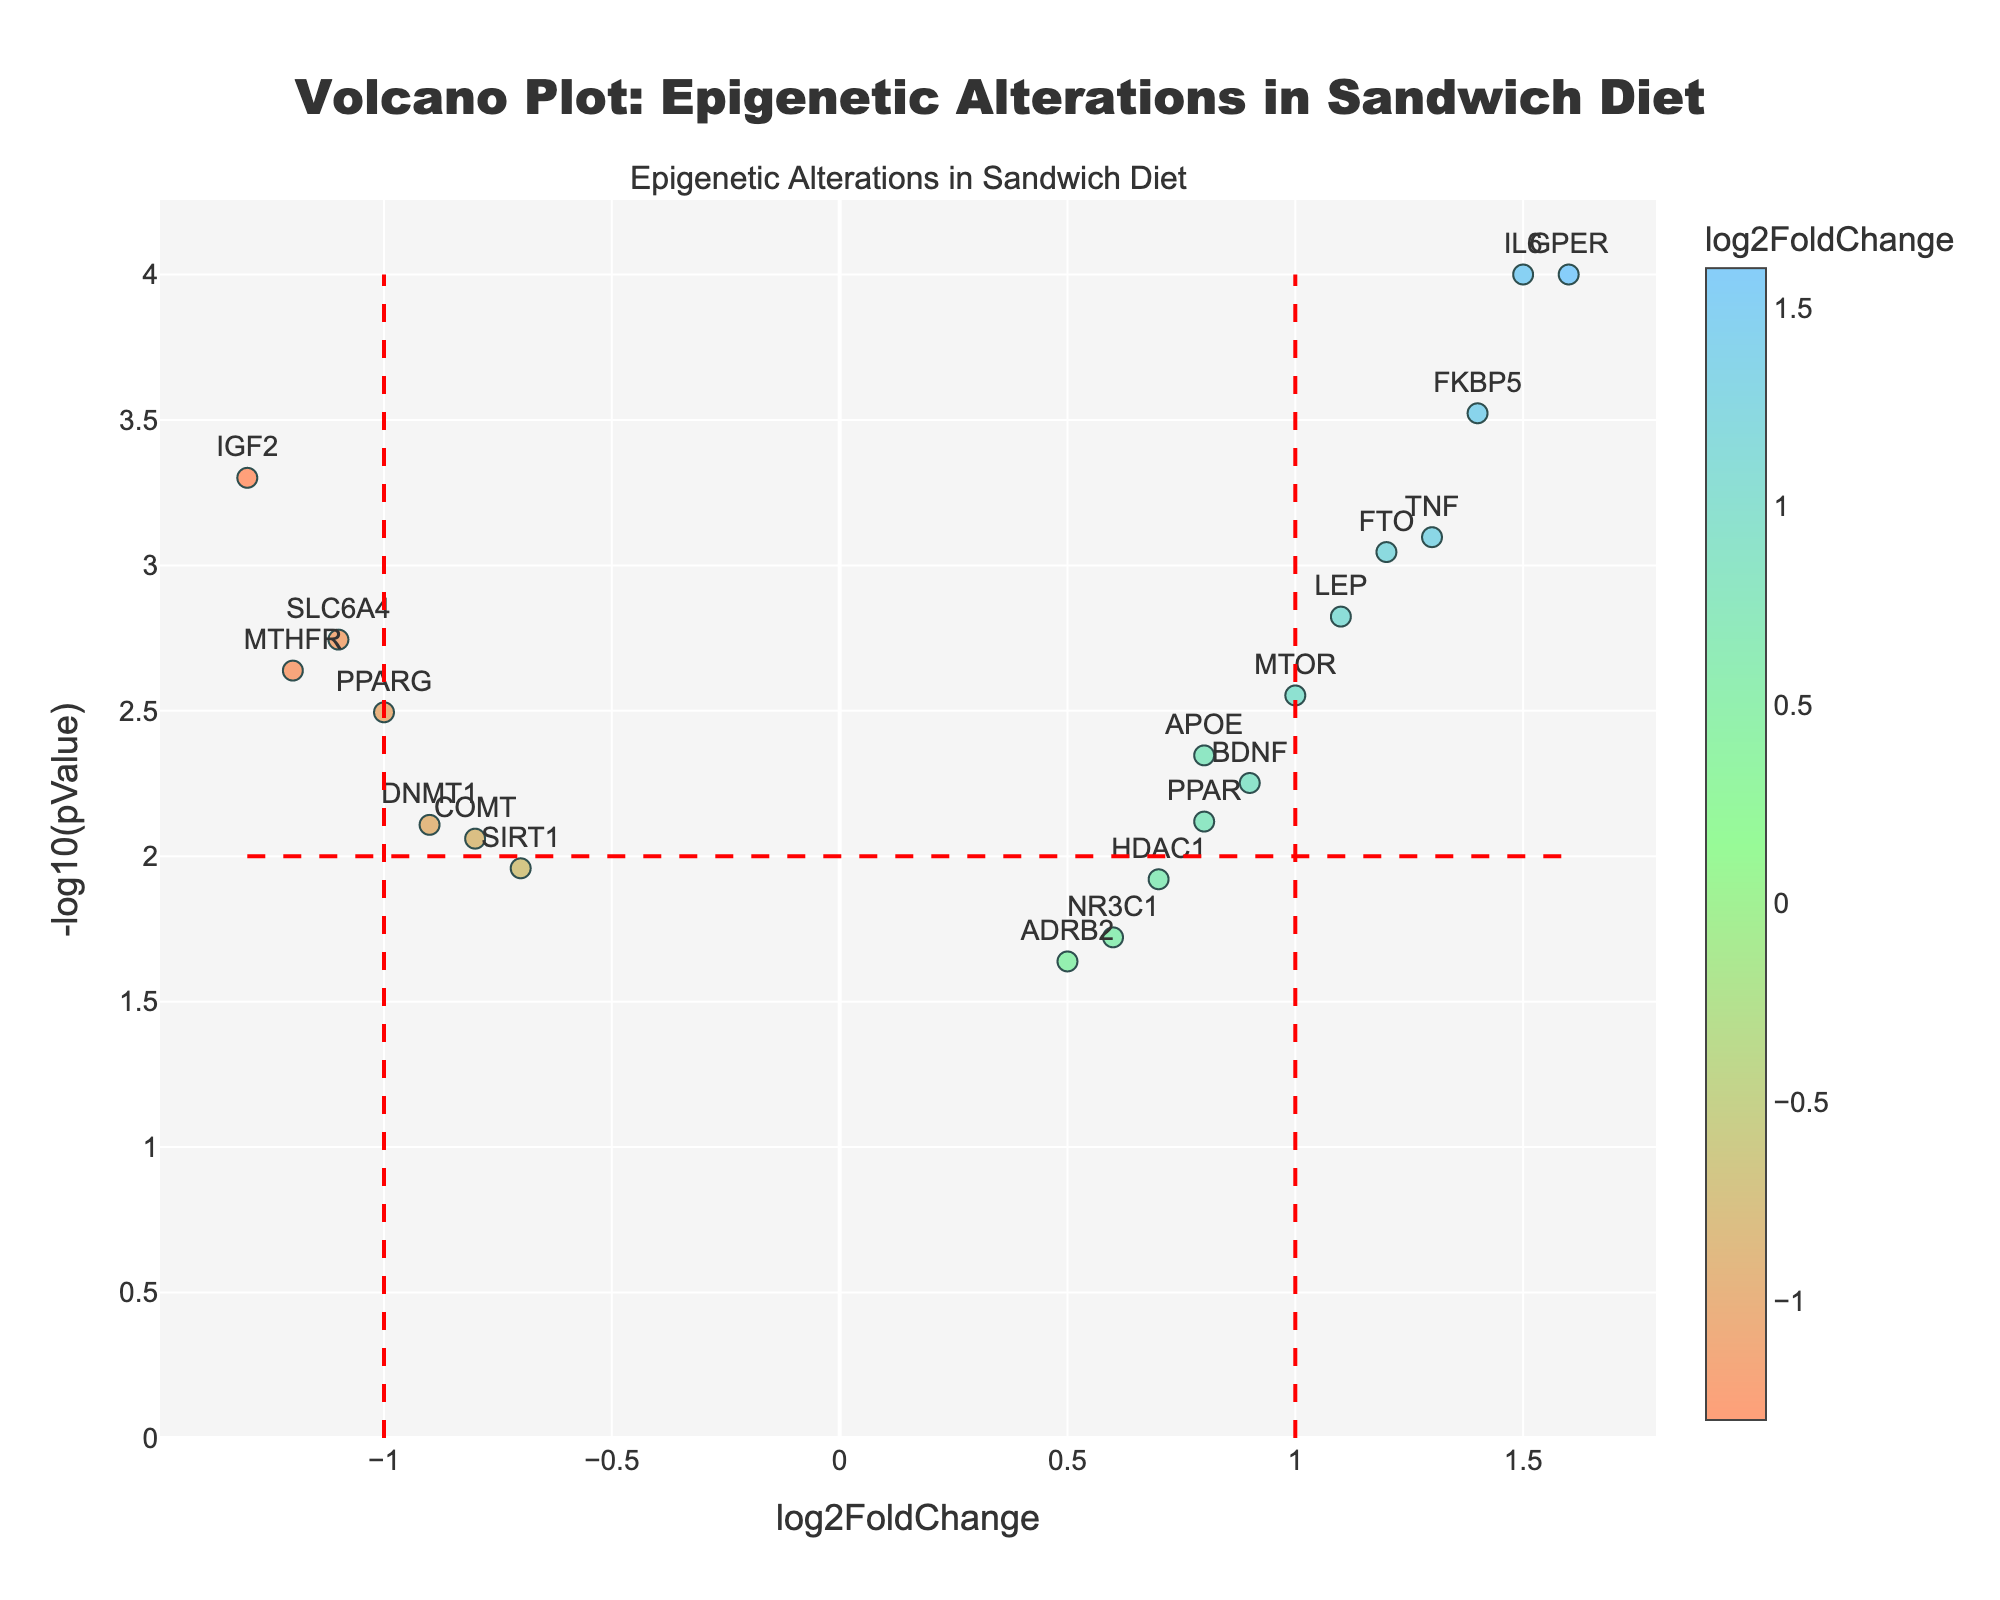What is the title of the volcano plot? The title of the plot is located at the top and usually provides information on what the plot represents. In this case, it's mentioned as 'Volcano Plot: Epigenetic Alterations in Sandwich Diet'.
Answer: Volcano Plot: Epigenetic Alterations in Sandwich Diet How many genes have a log2FoldChange greater than 1? To find the number of genes with a log2FoldChange greater than 1, we look at the x-axis and identify how many data points are located to the right of the vertical line at x=1. From the plot, the genes are IL6, TNF, FKBP5, GPER, FTO, and LEP, so there are 6 such genes.
Answer: 6 Which gene has the highest p-value? To determine the gene with the highest p-value, we look for the data point with the smallest -log10(pValue) on the y-axis. The gene near the bottom of the plot with the smallest y value is ADRB2.
Answer: ADRB2 What is the significance threshold for p-values in this plot? The significance threshold for p-values corresponds to the horizontal line on the plot at -log10(pValue) = 2. This value represents a p-value of 0.01 (10^-2).
Answer: 0.01 Which gene shows the highest magnitude of log2FoldChange? The gene with the highest magnitude of log2FoldChange will be the one farthest from the y-axis (either positive or negative). Visually, GPER shows the highest positive log2FoldChange (1.6), while IGF2 shows the highest negative log2FoldChange (-1.3). Thus, GPER has the highest magnitude if only one should be selected.
Answer: GPER Which gene is the most significantly upregulated? The most significantly upregulated gene will have a high positive log2FoldChange and a low p-value (high -log10(pValue)). GPER stands out as it has the highest log2FoldChange (1.6) and also a very low p-value (high y value).
Answer: GPER Are there more upregulated or downregulated genes above the significance threshold? To determine this, count the genes above the horizontal significance threshold (-log10(pValue) = 2) and see how many are on the left vs. the right of the y-axis. There are 6 upregulated genes (right of zero) and 6 downregulated genes (left of zero), both above the threshold.
Answer: Equal (6 each) Which gene's data point is the closest to the origin of the plot? The closest data point to the origin will be the one with both values (log2FoldChange and -log10(pValue)) the smallest. ADRB2 is the closest, given its values are log2FoldChange = 0.5 and -log10(pValue) is low.
Answer: ADRB2 